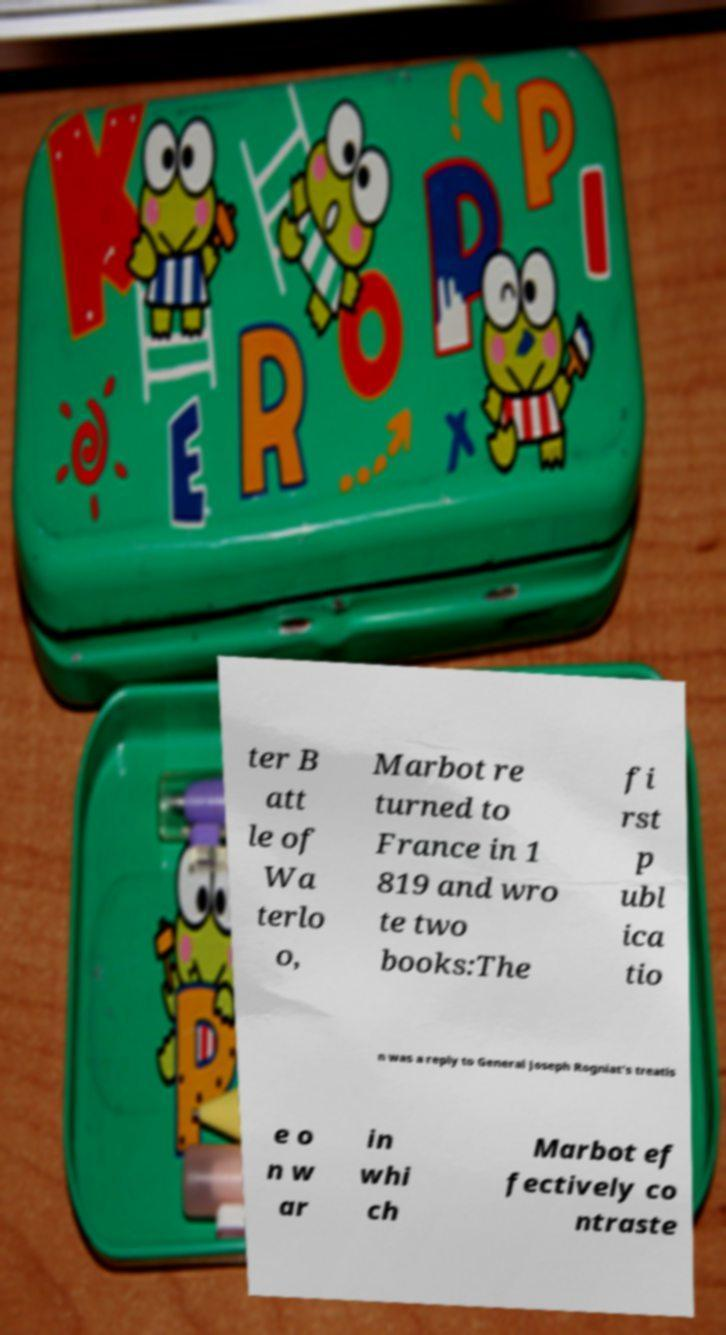Please identify and transcribe the text found in this image. ter B att le of Wa terlo o, Marbot re turned to France in 1 819 and wro te two books:The fi rst p ubl ica tio n was a reply to General Joseph Rogniat’s treatis e o n w ar in whi ch Marbot ef fectively co ntraste 